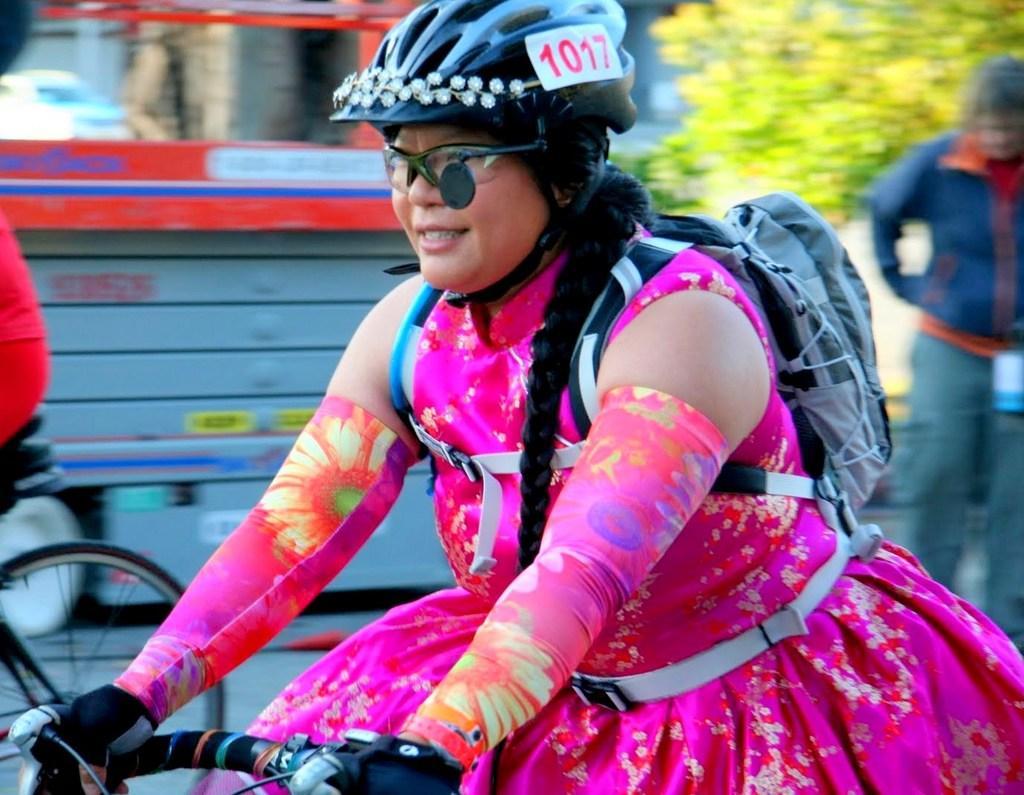Could you give a brief overview of what you see in this image? In this picture i can see man standing on road,he's wearing a blue color jacket and back side of him i can see a trees. On the middle a woman riding on bicycle and she is wearing spectacles and she is wearing pink color colorful dress and she is wearing back pack along with helmet , on the helmet i can see a 1012 she is wearing gloves on her hand. On the left side i can see bicycle wheel. I can see a backside of the image there is a car. 